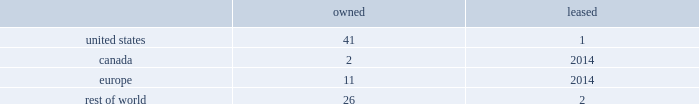While we have remediated the previously-identified material weakness in our internal control over financial reporting , we may identify other material weaknesses in the future .
In november 2017 , we restated our consolidated financial statements for the quarters ended april 1 , 2017 and july 1 , 2017 in order to correctly classify cash receipts from the payments on sold receivables ( which are cash receipts on the underlying trade receivables that have already been securitized ) to cash provided by investing activities ( from cash provided by operating activities ) within our condensed consolidated statements of cash flows .
In connection with these restatements , management identified a material weakness in our internal control over financial reporting related to the misapplication of accounting standards update 2016-15 .
Specifically , we did not maintain effective controls over the adoption of new accounting standards , including communication with the appropriate individuals in coming to our conclusions on the application of new accounting standards .
As a result of this material weakness , our management concluded that we did not maintain effective internal control over financial reporting as of april 1 , 2017 and july 1 , 2017 .
While we have remediated the material weakness and our management has determined that our disclosure controls and procedures were effective as of december 30 , 2017 , there can be no assurance that our controls will remain adequate .
The effectiveness of our internal control over financial reporting is subject to various inherent limitations , including judgments used in decision-making , the nature and complexity of the transactions we undertake , assumptions about the likelihood of future events , the soundness of our systems , cost limitations , and other limitations .
If other material weaknesses or significant deficiencies in our internal control are discovered or occur in the future or we otherwise must restate our financial statements , it could materially and adversely affect our business and results of operations or financial condition , restrict our ability to access the capital markets , require us to expend significant resources to correct the weaknesses or deficiencies , subject us to fines , penalties , investigations or judgments , harm our reputation , or otherwise cause a decline in investor confidence .
Item 1b .
Unresolved staff comments .
Item 2 .
Properties .
Our corporate co-headquarters are located in pittsburgh , pennsylvania and chicago , illinois .
Our co-headquarters are leased and house certain executive offices , our u.s .
Business units , and our administrative , finance , legal , and human resource functions .
We maintain additional owned and leased offices throughout the regions in which we operate .
We manufacture our products in our network of manufacturing and processing facilities located throughout the world .
As of december 30 , 2017 , we operated 83 manufacturing and processing facilities .
We own 80 and lease three of these facilities .
Our manufacturing and processing facilities count by segment as of december 30 , 2017 was: .
We maintain all of our manufacturing and processing facilities in good condition and believe they are suitable and are adequate for our present needs .
We also enter into co-manufacturing arrangements with third parties if we determine it is advantageous to outsource the production of any of our products .
Item 3 .
Legal proceedings .
We are routinely involved in legal proceedings , claims , and governmental inquiries , inspections or investigations ( 201clegal matters 201d ) arising in the ordinary course of our business .
While we cannot predict with certainty the results of legal matters in which we are currently involved or may in the future be involved , we do not expect that the ultimate costs to resolve any of the legal matters that are currently pending will have a material adverse effect on our financial condition or results of operations .
Item 4 .
Mine safety disclosures .
Not applicable. .
What percent of total facilities are leased? 
Computations: (3 / 83)
Answer: 0.03614. 